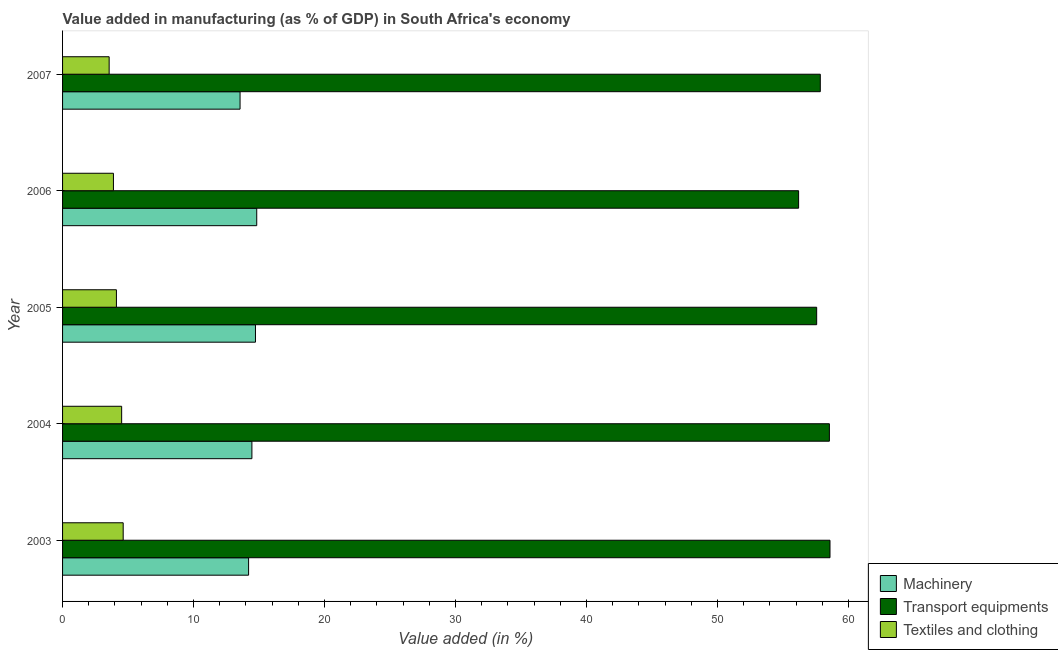Are the number of bars per tick equal to the number of legend labels?
Ensure brevity in your answer.  Yes. How many bars are there on the 2nd tick from the bottom?
Provide a short and direct response. 3. What is the label of the 1st group of bars from the top?
Make the answer very short. 2007. In how many cases, is the number of bars for a given year not equal to the number of legend labels?
Your answer should be very brief. 0. What is the value added in manufacturing transport equipments in 2006?
Provide a succinct answer. 56.19. Across all years, what is the maximum value added in manufacturing transport equipments?
Ensure brevity in your answer.  58.59. Across all years, what is the minimum value added in manufacturing textile and clothing?
Provide a succinct answer. 3.56. In which year was the value added in manufacturing machinery maximum?
Provide a succinct answer. 2006. What is the total value added in manufacturing textile and clothing in the graph?
Your response must be concise. 20.69. What is the difference between the value added in manufacturing textile and clothing in 2003 and that in 2005?
Ensure brevity in your answer.  0.52. What is the difference between the value added in manufacturing transport equipments in 2007 and the value added in manufacturing machinery in 2005?
Give a very brief answer. 43.12. What is the average value added in manufacturing machinery per year?
Your answer should be very brief. 14.35. In the year 2003, what is the difference between the value added in manufacturing textile and clothing and value added in manufacturing transport equipments?
Ensure brevity in your answer.  -53.96. What is the ratio of the value added in manufacturing machinery in 2003 to that in 2006?
Your answer should be compact. 0.96. What is the difference between the highest and the second highest value added in manufacturing machinery?
Offer a very short reply. 0.1. In how many years, is the value added in manufacturing textile and clothing greater than the average value added in manufacturing textile and clothing taken over all years?
Ensure brevity in your answer.  2. What does the 2nd bar from the top in 2005 represents?
Offer a very short reply. Transport equipments. What does the 1st bar from the bottom in 2007 represents?
Offer a terse response. Machinery. Is it the case that in every year, the sum of the value added in manufacturing machinery and value added in manufacturing transport equipments is greater than the value added in manufacturing textile and clothing?
Ensure brevity in your answer.  Yes. How many years are there in the graph?
Offer a very short reply. 5. What is the difference between two consecutive major ticks on the X-axis?
Your answer should be very brief. 10. Does the graph contain grids?
Make the answer very short. No. Where does the legend appear in the graph?
Offer a very short reply. Bottom right. What is the title of the graph?
Ensure brevity in your answer.  Value added in manufacturing (as % of GDP) in South Africa's economy. Does "Nuclear sources" appear as one of the legend labels in the graph?
Your response must be concise. No. What is the label or title of the X-axis?
Offer a very short reply. Value added (in %). What is the Value added (in %) of Machinery in 2003?
Provide a short and direct response. 14.2. What is the Value added (in %) of Transport equipments in 2003?
Offer a very short reply. 58.59. What is the Value added (in %) in Textiles and clothing in 2003?
Your response must be concise. 4.63. What is the Value added (in %) of Machinery in 2004?
Offer a very short reply. 14.45. What is the Value added (in %) of Transport equipments in 2004?
Provide a short and direct response. 58.54. What is the Value added (in %) in Textiles and clothing in 2004?
Offer a terse response. 4.51. What is the Value added (in %) of Machinery in 2005?
Give a very brief answer. 14.73. What is the Value added (in %) of Transport equipments in 2005?
Provide a short and direct response. 57.57. What is the Value added (in %) of Textiles and clothing in 2005?
Offer a very short reply. 4.11. What is the Value added (in %) of Machinery in 2006?
Your response must be concise. 14.82. What is the Value added (in %) of Transport equipments in 2006?
Your response must be concise. 56.19. What is the Value added (in %) in Textiles and clothing in 2006?
Offer a very short reply. 3.88. What is the Value added (in %) in Machinery in 2007?
Make the answer very short. 13.55. What is the Value added (in %) in Transport equipments in 2007?
Offer a terse response. 57.85. What is the Value added (in %) in Textiles and clothing in 2007?
Make the answer very short. 3.56. Across all years, what is the maximum Value added (in %) in Machinery?
Give a very brief answer. 14.82. Across all years, what is the maximum Value added (in %) in Transport equipments?
Offer a very short reply. 58.59. Across all years, what is the maximum Value added (in %) of Textiles and clothing?
Make the answer very short. 4.63. Across all years, what is the minimum Value added (in %) in Machinery?
Ensure brevity in your answer.  13.55. Across all years, what is the minimum Value added (in %) of Transport equipments?
Offer a very short reply. 56.19. Across all years, what is the minimum Value added (in %) in Textiles and clothing?
Your answer should be very brief. 3.56. What is the total Value added (in %) in Machinery in the graph?
Your answer should be compact. 71.76. What is the total Value added (in %) of Transport equipments in the graph?
Provide a succinct answer. 288.73. What is the total Value added (in %) in Textiles and clothing in the graph?
Provide a succinct answer. 20.69. What is the difference between the Value added (in %) in Machinery in 2003 and that in 2004?
Offer a very short reply. -0.25. What is the difference between the Value added (in %) in Transport equipments in 2003 and that in 2004?
Make the answer very short. 0.05. What is the difference between the Value added (in %) in Textiles and clothing in 2003 and that in 2004?
Make the answer very short. 0.12. What is the difference between the Value added (in %) of Machinery in 2003 and that in 2005?
Make the answer very short. -0.52. What is the difference between the Value added (in %) of Transport equipments in 2003 and that in 2005?
Offer a terse response. 1.02. What is the difference between the Value added (in %) of Textiles and clothing in 2003 and that in 2005?
Ensure brevity in your answer.  0.52. What is the difference between the Value added (in %) of Machinery in 2003 and that in 2006?
Provide a succinct answer. -0.62. What is the difference between the Value added (in %) of Transport equipments in 2003 and that in 2006?
Give a very brief answer. 2.4. What is the difference between the Value added (in %) of Textiles and clothing in 2003 and that in 2006?
Give a very brief answer. 0.75. What is the difference between the Value added (in %) of Machinery in 2003 and that in 2007?
Keep it short and to the point. 0.65. What is the difference between the Value added (in %) of Transport equipments in 2003 and that in 2007?
Offer a very short reply. 0.74. What is the difference between the Value added (in %) in Textiles and clothing in 2003 and that in 2007?
Make the answer very short. 1.07. What is the difference between the Value added (in %) in Machinery in 2004 and that in 2005?
Provide a short and direct response. -0.27. What is the difference between the Value added (in %) in Transport equipments in 2004 and that in 2005?
Provide a short and direct response. 0.97. What is the difference between the Value added (in %) of Textiles and clothing in 2004 and that in 2005?
Ensure brevity in your answer.  0.4. What is the difference between the Value added (in %) in Machinery in 2004 and that in 2006?
Offer a very short reply. -0.37. What is the difference between the Value added (in %) in Transport equipments in 2004 and that in 2006?
Your answer should be very brief. 2.35. What is the difference between the Value added (in %) in Textiles and clothing in 2004 and that in 2006?
Your answer should be compact. 0.63. What is the difference between the Value added (in %) of Machinery in 2004 and that in 2007?
Give a very brief answer. 0.9. What is the difference between the Value added (in %) in Transport equipments in 2004 and that in 2007?
Offer a very short reply. 0.69. What is the difference between the Value added (in %) in Textiles and clothing in 2004 and that in 2007?
Your answer should be compact. 0.95. What is the difference between the Value added (in %) of Machinery in 2005 and that in 2006?
Ensure brevity in your answer.  -0.1. What is the difference between the Value added (in %) in Transport equipments in 2005 and that in 2006?
Your answer should be very brief. 1.38. What is the difference between the Value added (in %) of Textiles and clothing in 2005 and that in 2006?
Your answer should be compact. 0.23. What is the difference between the Value added (in %) in Machinery in 2005 and that in 2007?
Give a very brief answer. 1.18. What is the difference between the Value added (in %) of Transport equipments in 2005 and that in 2007?
Offer a very short reply. -0.28. What is the difference between the Value added (in %) of Textiles and clothing in 2005 and that in 2007?
Offer a very short reply. 0.56. What is the difference between the Value added (in %) of Machinery in 2006 and that in 2007?
Give a very brief answer. 1.27. What is the difference between the Value added (in %) in Transport equipments in 2006 and that in 2007?
Provide a short and direct response. -1.66. What is the difference between the Value added (in %) of Textiles and clothing in 2006 and that in 2007?
Offer a terse response. 0.33. What is the difference between the Value added (in %) of Machinery in 2003 and the Value added (in %) of Transport equipments in 2004?
Offer a very short reply. -44.34. What is the difference between the Value added (in %) of Machinery in 2003 and the Value added (in %) of Textiles and clothing in 2004?
Provide a succinct answer. 9.69. What is the difference between the Value added (in %) of Transport equipments in 2003 and the Value added (in %) of Textiles and clothing in 2004?
Offer a terse response. 54.08. What is the difference between the Value added (in %) of Machinery in 2003 and the Value added (in %) of Transport equipments in 2005?
Ensure brevity in your answer.  -43.37. What is the difference between the Value added (in %) of Machinery in 2003 and the Value added (in %) of Textiles and clothing in 2005?
Keep it short and to the point. 10.09. What is the difference between the Value added (in %) in Transport equipments in 2003 and the Value added (in %) in Textiles and clothing in 2005?
Your response must be concise. 54.47. What is the difference between the Value added (in %) in Machinery in 2003 and the Value added (in %) in Transport equipments in 2006?
Provide a short and direct response. -41.99. What is the difference between the Value added (in %) of Machinery in 2003 and the Value added (in %) of Textiles and clothing in 2006?
Your answer should be very brief. 10.32. What is the difference between the Value added (in %) in Transport equipments in 2003 and the Value added (in %) in Textiles and clothing in 2006?
Offer a terse response. 54.7. What is the difference between the Value added (in %) in Machinery in 2003 and the Value added (in %) in Transport equipments in 2007?
Offer a very short reply. -43.64. What is the difference between the Value added (in %) in Machinery in 2003 and the Value added (in %) in Textiles and clothing in 2007?
Ensure brevity in your answer.  10.65. What is the difference between the Value added (in %) in Transport equipments in 2003 and the Value added (in %) in Textiles and clothing in 2007?
Offer a very short reply. 55.03. What is the difference between the Value added (in %) of Machinery in 2004 and the Value added (in %) of Transport equipments in 2005?
Offer a terse response. -43.11. What is the difference between the Value added (in %) of Machinery in 2004 and the Value added (in %) of Textiles and clothing in 2005?
Make the answer very short. 10.34. What is the difference between the Value added (in %) of Transport equipments in 2004 and the Value added (in %) of Textiles and clothing in 2005?
Offer a very short reply. 54.43. What is the difference between the Value added (in %) of Machinery in 2004 and the Value added (in %) of Transport equipments in 2006?
Your answer should be very brief. -41.74. What is the difference between the Value added (in %) of Machinery in 2004 and the Value added (in %) of Textiles and clothing in 2006?
Keep it short and to the point. 10.57. What is the difference between the Value added (in %) of Transport equipments in 2004 and the Value added (in %) of Textiles and clothing in 2006?
Provide a succinct answer. 54.66. What is the difference between the Value added (in %) of Machinery in 2004 and the Value added (in %) of Transport equipments in 2007?
Your response must be concise. -43.39. What is the difference between the Value added (in %) in Machinery in 2004 and the Value added (in %) in Textiles and clothing in 2007?
Your response must be concise. 10.9. What is the difference between the Value added (in %) of Transport equipments in 2004 and the Value added (in %) of Textiles and clothing in 2007?
Your answer should be very brief. 54.98. What is the difference between the Value added (in %) of Machinery in 2005 and the Value added (in %) of Transport equipments in 2006?
Keep it short and to the point. -41.46. What is the difference between the Value added (in %) of Machinery in 2005 and the Value added (in %) of Textiles and clothing in 2006?
Give a very brief answer. 10.84. What is the difference between the Value added (in %) of Transport equipments in 2005 and the Value added (in %) of Textiles and clothing in 2006?
Provide a short and direct response. 53.69. What is the difference between the Value added (in %) in Machinery in 2005 and the Value added (in %) in Transport equipments in 2007?
Offer a terse response. -43.12. What is the difference between the Value added (in %) in Machinery in 2005 and the Value added (in %) in Textiles and clothing in 2007?
Provide a short and direct response. 11.17. What is the difference between the Value added (in %) of Transport equipments in 2005 and the Value added (in %) of Textiles and clothing in 2007?
Provide a short and direct response. 54.01. What is the difference between the Value added (in %) of Machinery in 2006 and the Value added (in %) of Transport equipments in 2007?
Your response must be concise. -43.02. What is the difference between the Value added (in %) in Machinery in 2006 and the Value added (in %) in Textiles and clothing in 2007?
Your response must be concise. 11.27. What is the difference between the Value added (in %) of Transport equipments in 2006 and the Value added (in %) of Textiles and clothing in 2007?
Offer a very short reply. 52.63. What is the average Value added (in %) in Machinery per year?
Keep it short and to the point. 14.35. What is the average Value added (in %) in Transport equipments per year?
Your answer should be compact. 57.75. What is the average Value added (in %) in Textiles and clothing per year?
Keep it short and to the point. 4.14. In the year 2003, what is the difference between the Value added (in %) of Machinery and Value added (in %) of Transport equipments?
Your answer should be very brief. -44.38. In the year 2003, what is the difference between the Value added (in %) of Machinery and Value added (in %) of Textiles and clothing?
Provide a short and direct response. 9.57. In the year 2003, what is the difference between the Value added (in %) in Transport equipments and Value added (in %) in Textiles and clothing?
Offer a terse response. 53.96. In the year 2004, what is the difference between the Value added (in %) of Machinery and Value added (in %) of Transport equipments?
Your response must be concise. -44.09. In the year 2004, what is the difference between the Value added (in %) in Machinery and Value added (in %) in Textiles and clothing?
Give a very brief answer. 9.94. In the year 2004, what is the difference between the Value added (in %) of Transport equipments and Value added (in %) of Textiles and clothing?
Offer a terse response. 54.03. In the year 2005, what is the difference between the Value added (in %) of Machinery and Value added (in %) of Transport equipments?
Offer a terse response. -42.84. In the year 2005, what is the difference between the Value added (in %) in Machinery and Value added (in %) in Textiles and clothing?
Your answer should be very brief. 10.61. In the year 2005, what is the difference between the Value added (in %) of Transport equipments and Value added (in %) of Textiles and clothing?
Keep it short and to the point. 53.46. In the year 2006, what is the difference between the Value added (in %) of Machinery and Value added (in %) of Transport equipments?
Give a very brief answer. -41.37. In the year 2006, what is the difference between the Value added (in %) of Machinery and Value added (in %) of Textiles and clothing?
Your answer should be very brief. 10.94. In the year 2006, what is the difference between the Value added (in %) in Transport equipments and Value added (in %) in Textiles and clothing?
Your answer should be compact. 52.31. In the year 2007, what is the difference between the Value added (in %) in Machinery and Value added (in %) in Transport equipments?
Offer a terse response. -44.3. In the year 2007, what is the difference between the Value added (in %) in Machinery and Value added (in %) in Textiles and clothing?
Your response must be concise. 9.99. In the year 2007, what is the difference between the Value added (in %) in Transport equipments and Value added (in %) in Textiles and clothing?
Your answer should be compact. 54.29. What is the ratio of the Value added (in %) of Machinery in 2003 to that in 2004?
Offer a very short reply. 0.98. What is the ratio of the Value added (in %) in Machinery in 2003 to that in 2005?
Make the answer very short. 0.96. What is the ratio of the Value added (in %) in Transport equipments in 2003 to that in 2005?
Provide a short and direct response. 1.02. What is the ratio of the Value added (in %) in Textiles and clothing in 2003 to that in 2005?
Give a very brief answer. 1.13. What is the ratio of the Value added (in %) in Machinery in 2003 to that in 2006?
Your answer should be compact. 0.96. What is the ratio of the Value added (in %) of Transport equipments in 2003 to that in 2006?
Make the answer very short. 1.04. What is the ratio of the Value added (in %) in Textiles and clothing in 2003 to that in 2006?
Ensure brevity in your answer.  1.19. What is the ratio of the Value added (in %) of Machinery in 2003 to that in 2007?
Provide a short and direct response. 1.05. What is the ratio of the Value added (in %) of Transport equipments in 2003 to that in 2007?
Keep it short and to the point. 1.01. What is the ratio of the Value added (in %) in Textiles and clothing in 2003 to that in 2007?
Make the answer very short. 1.3. What is the ratio of the Value added (in %) of Machinery in 2004 to that in 2005?
Provide a succinct answer. 0.98. What is the ratio of the Value added (in %) of Transport equipments in 2004 to that in 2005?
Offer a very short reply. 1.02. What is the ratio of the Value added (in %) of Textiles and clothing in 2004 to that in 2005?
Your answer should be very brief. 1.1. What is the ratio of the Value added (in %) of Machinery in 2004 to that in 2006?
Offer a very short reply. 0.98. What is the ratio of the Value added (in %) in Transport equipments in 2004 to that in 2006?
Your answer should be very brief. 1.04. What is the ratio of the Value added (in %) in Textiles and clothing in 2004 to that in 2006?
Provide a succinct answer. 1.16. What is the ratio of the Value added (in %) of Machinery in 2004 to that in 2007?
Your answer should be very brief. 1.07. What is the ratio of the Value added (in %) of Textiles and clothing in 2004 to that in 2007?
Your answer should be compact. 1.27. What is the ratio of the Value added (in %) in Transport equipments in 2005 to that in 2006?
Provide a short and direct response. 1.02. What is the ratio of the Value added (in %) in Textiles and clothing in 2005 to that in 2006?
Provide a succinct answer. 1.06. What is the ratio of the Value added (in %) of Machinery in 2005 to that in 2007?
Offer a terse response. 1.09. What is the ratio of the Value added (in %) in Textiles and clothing in 2005 to that in 2007?
Make the answer very short. 1.16. What is the ratio of the Value added (in %) of Machinery in 2006 to that in 2007?
Ensure brevity in your answer.  1.09. What is the ratio of the Value added (in %) of Transport equipments in 2006 to that in 2007?
Make the answer very short. 0.97. What is the ratio of the Value added (in %) of Textiles and clothing in 2006 to that in 2007?
Provide a succinct answer. 1.09. What is the difference between the highest and the second highest Value added (in %) in Machinery?
Ensure brevity in your answer.  0.1. What is the difference between the highest and the second highest Value added (in %) in Transport equipments?
Provide a short and direct response. 0.05. What is the difference between the highest and the second highest Value added (in %) of Textiles and clothing?
Make the answer very short. 0.12. What is the difference between the highest and the lowest Value added (in %) of Machinery?
Offer a terse response. 1.27. What is the difference between the highest and the lowest Value added (in %) in Transport equipments?
Make the answer very short. 2.4. What is the difference between the highest and the lowest Value added (in %) in Textiles and clothing?
Provide a short and direct response. 1.07. 